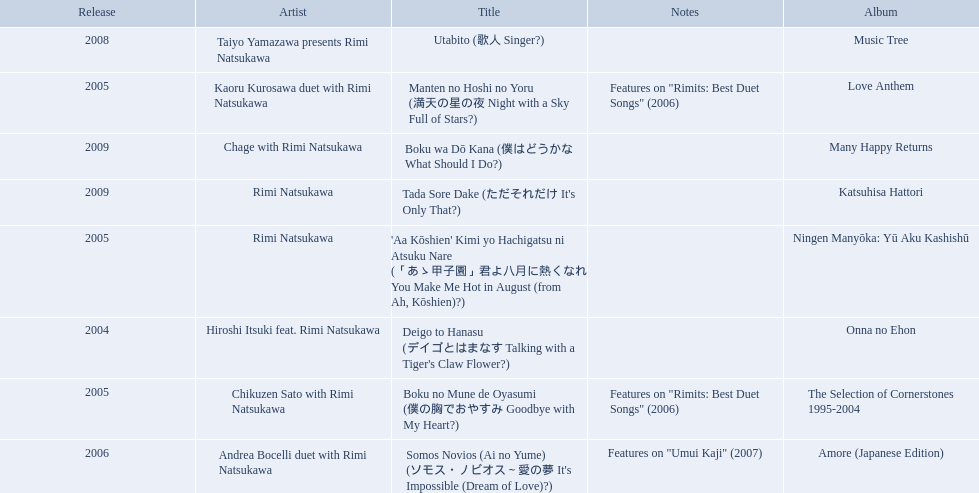Which title of the rimi natsukawa discography was released in the 2004? Deigo to Hanasu (デイゴとはまなす Talking with a Tiger's Claw Flower?). Which title has notes that features on/rimits. best duet songs\2006 Manten no Hoshi no Yoru (満天の星の夜 Night with a Sky Full of Stars?). Which title share the same notes as night with a sky full of stars? Boku no Mune de Oyasumi (僕の胸でおやすみ Goodbye with My Heart?). 